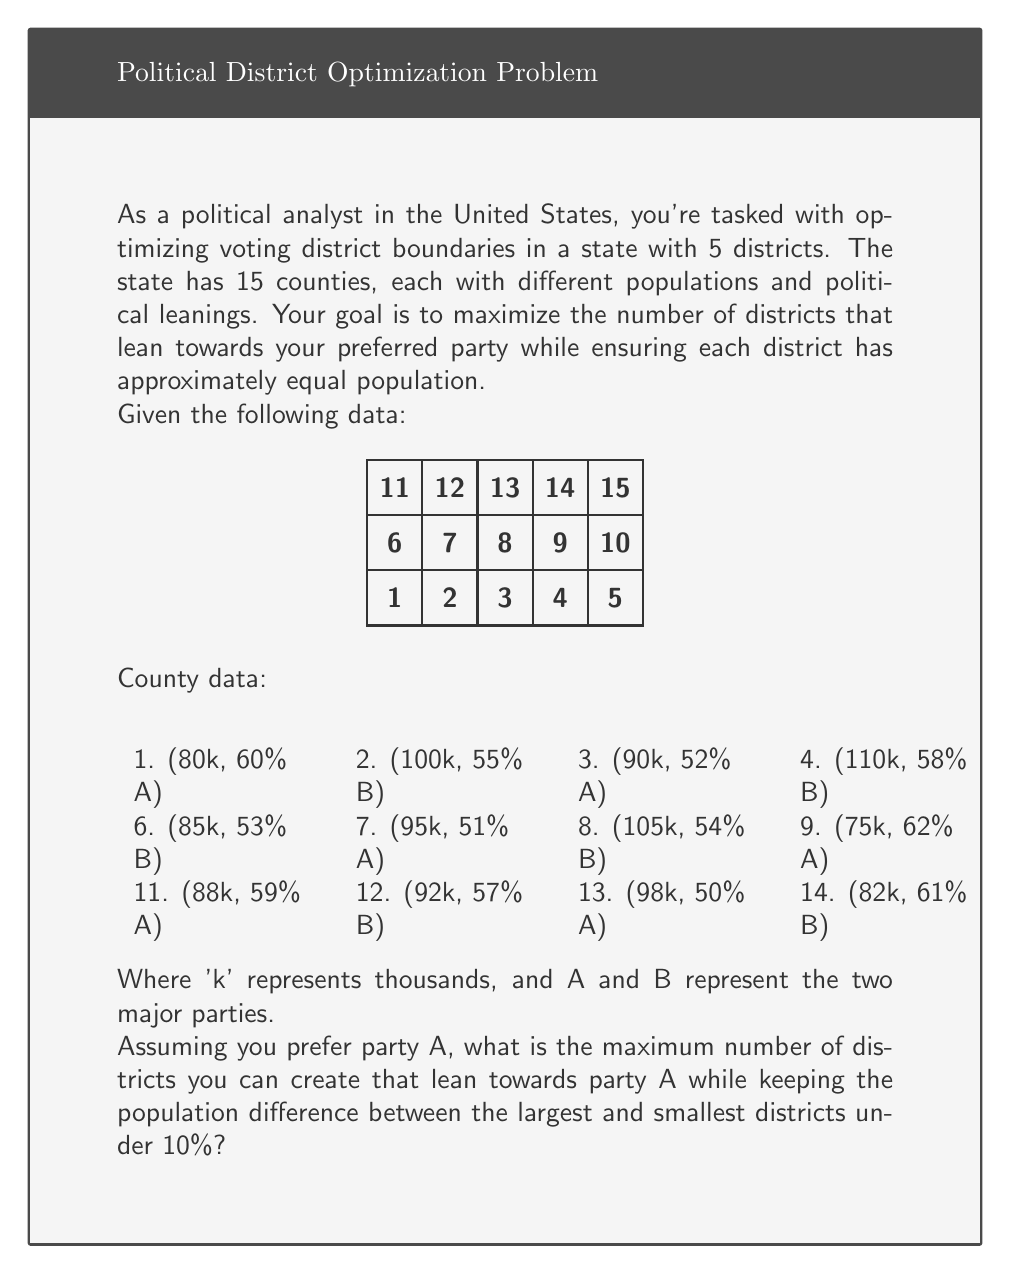Teach me how to tackle this problem. To solve this problem, we need to follow these steps:

1. Calculate the ideal population per district:
   Total population = 1300k
   Number of districts = 5
   Ideal population per district = 1300k / 5 = 260k

2. Determine the acceptable population range (within 10% difference):
   Minimum: 260k * 0.95 = 247k
   Maximum: 260k * 1.05 = 273k

3. Group counties to form districts that lean towards party A while staying within the population range. We'll use a greedy approach:

   District 1: Counties 1, 3, 5, 9
   Population: 80k + 90k + 70k + 75k = 315k (exceeds maximum)
   Remove county 9
   New population: 240k (within range)
   Leaning: (48k + 46.8k + 45.5k) / 240k = 58.5% A

   District 2: Counties 7, 9, 11, 13
   Population: 95k + 75k + 88k + 98k = 356k (exceeds maximum)
   Remove county 13
   New population: 258k (within range)
   Leaning: (48.45k + 46.5k + 51.92k) / 258k = 57.0% A

   District 3: Counties 13, 15
   Population: 98k + 110k = 208k (below minimum)
   Add county 6
   New population: 293k (exceeds maximum)
   Remove county 6
   Final population: 208k (below minimum, but best option)
   Leaning: (49k + 58.3k) / 208k = 51.6% A

   Remaining counties: 2, 4, 6, 8, 10, 12, 14
   Total remaining population: 684k

   District 4 and 5 must be formed from these remaining counties, which all lean towards party B.

4. Count the number of districts leaning towards party A: 3

Therefore, the maximum number of districts leaning towards party A is 3.
Answer: 3 districts 